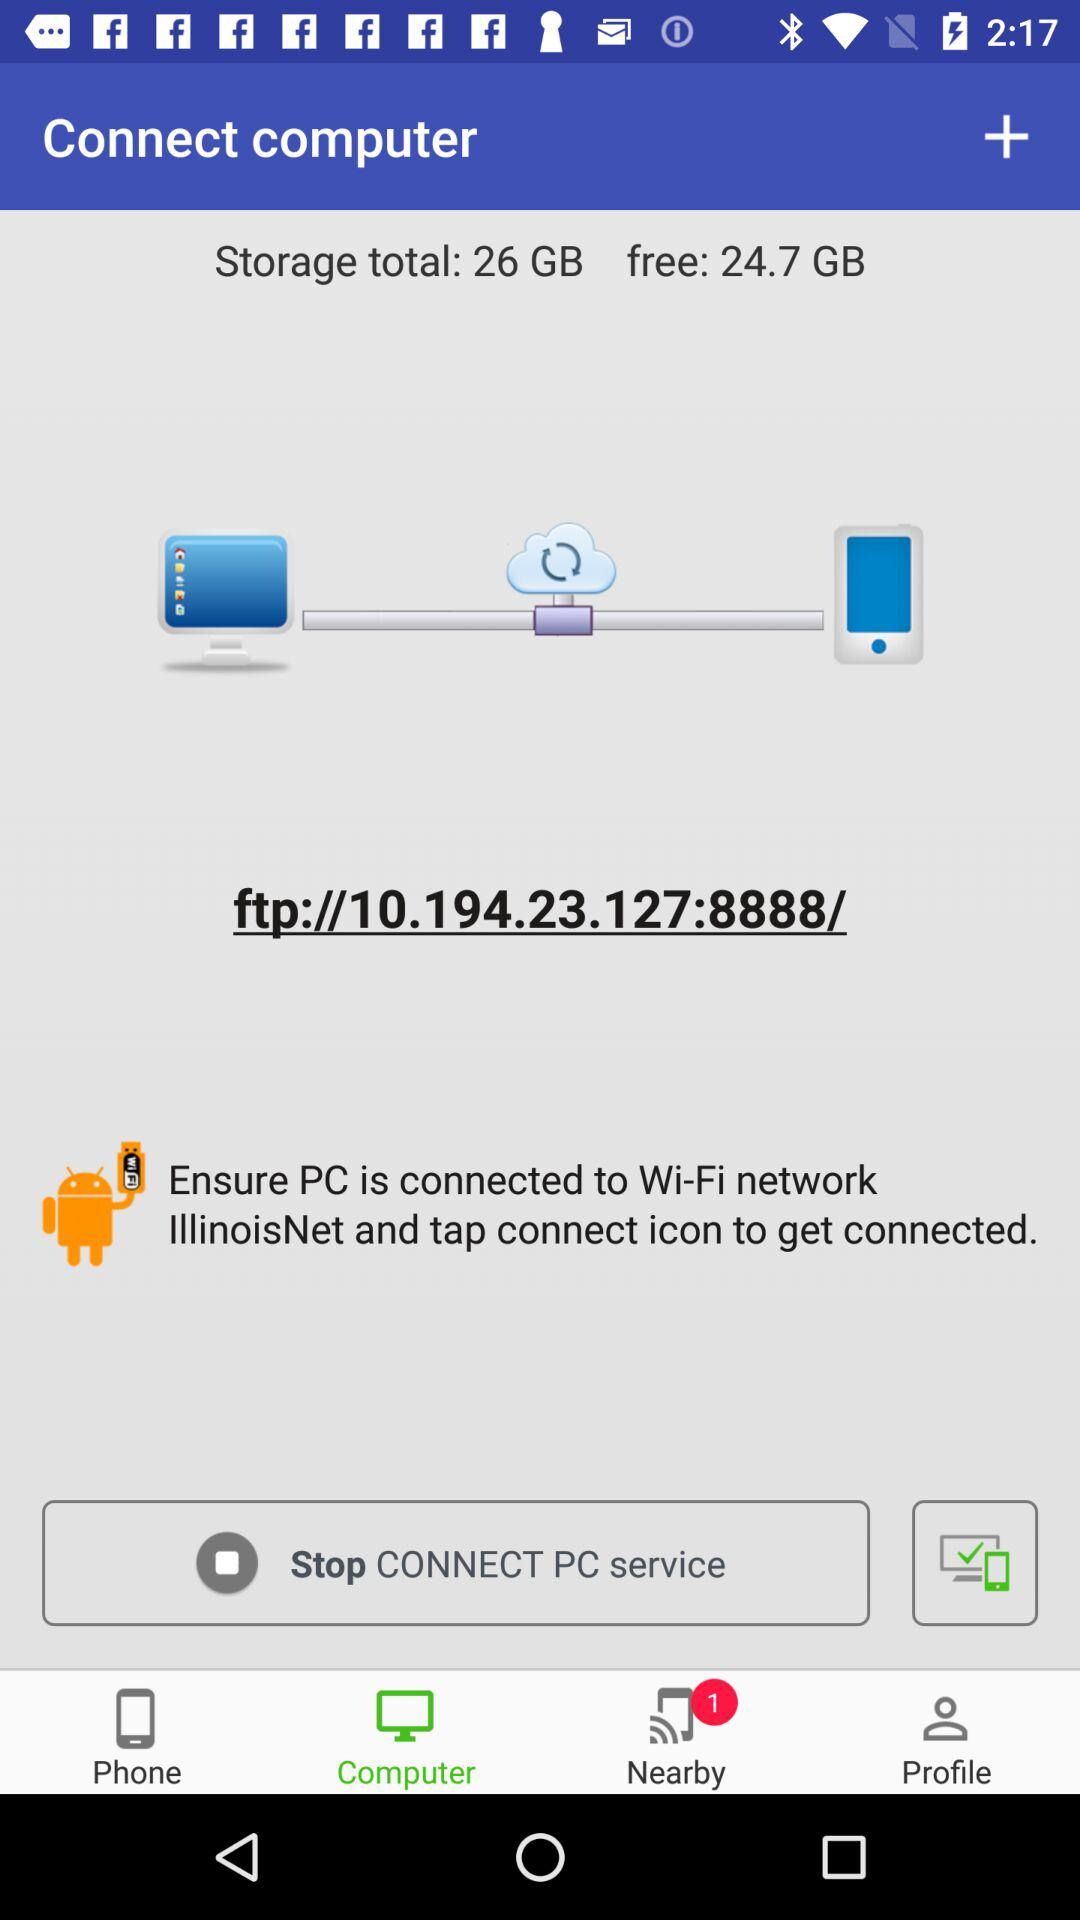Which option has been selected? The option that has been selected is "Computer". 